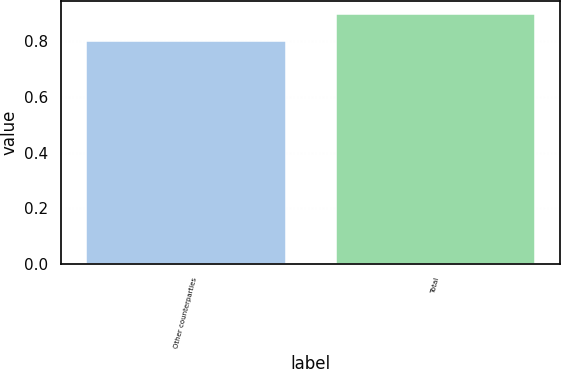<chart> <loc_0><loc_0><loc_500><loc_500><bar_chart><fcel>Other counterparties<fcel>Total<nl><fcel>0.8<fcel>0.9<nl></chart> 